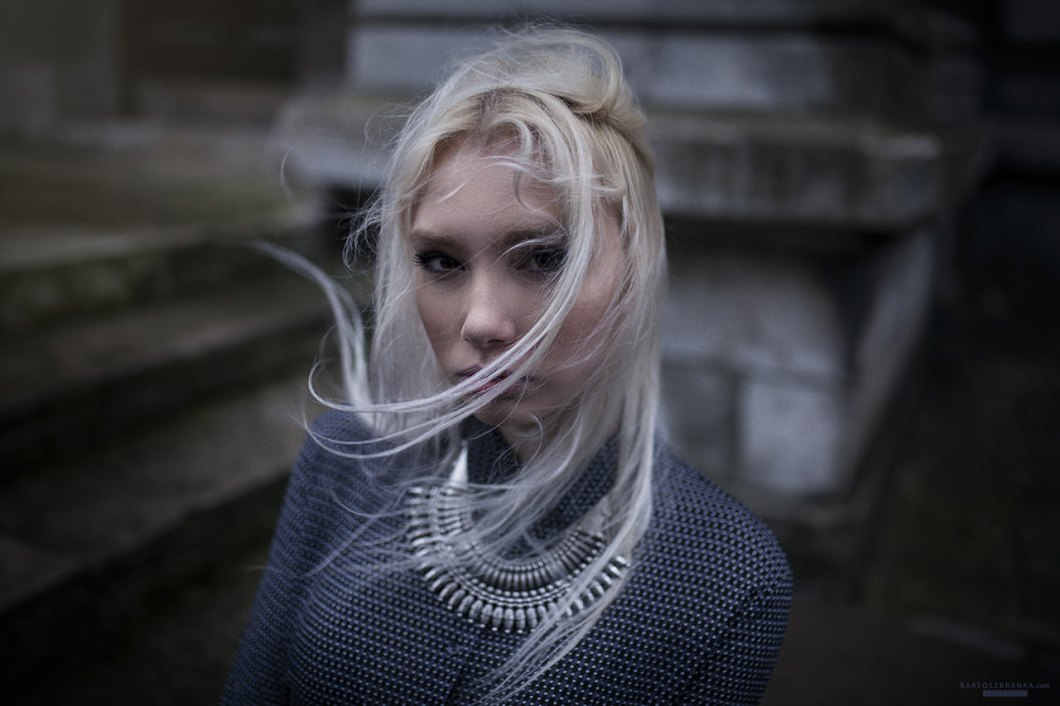What is the possible material of the woman's sweater, and how does it contribute to the overall aesthetic of the image? The woman's sweater appears to be crafted from a heavy knit fabric, possibly wool or a wool blend, judging by its chunky texture and the way it drapes over her form. The dark grey hue of the sweater accentuates the image's moody and contemplative atmosphere, harmonizing with the overcast weather and muted tones of the background. This material choice adds a tactile, cozy element to the portrait, implying warmth and depth, which stands in striking contrast to the light, ethereal quality of her hair and the slightly blurred, historical architecture in the backdrop. This interplay of textures—wool's robustness against the softness of her hair—creates a rich visual tapestry, increasing the depth and interest of the photograph. 